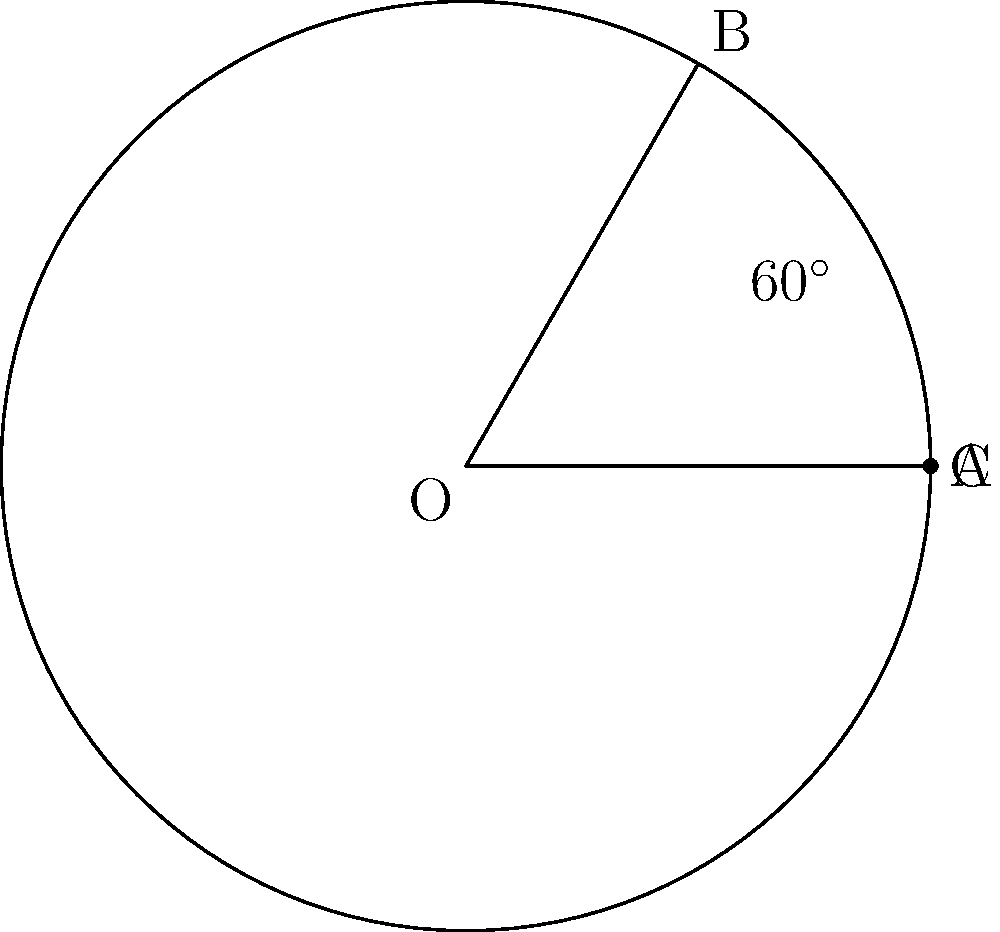In a regulation discus throwing circle with a radius of 1.25 meters, an athlete's throwing sector is limited to a 60° angle. If the athlete wants to practice throws within this sector, what is the area of the practice zone within the circle? Round your answer to two decimal places. To solve this problem, we need to calculate the area of a sector in a circle. Let's break it down step-by-step:

1) The formula for the area of a sector is:
   $$A = \frac{\theta}{360°} \pi r^2$$
   Where $\theta$ is the central angle in degrees, and $r$ is the radius.

2) We're given:
   - Radius $(r) = 1.25$ meters
   - Central angle $(\theta) = 60°$

3) Let's substitute these values into our formula:
   $$A = \frac{60°}{360°} \pi (1.25\text{ m})^2$$

4) Simplify:
   $$A = \frac{1}{6} \pi (1.5625\text{ m}^2)$$

5) Calculate:
   $$A = 0.8181... \text{ m}^2$$

6) Rounding to two decimal places:
   $$A \approx 0.82 \text{ m}^2$$

This area represents the portion of the discus circle where the athlete will be practicing their throws.
Answer: $0.82 \text{ m}^2$ 